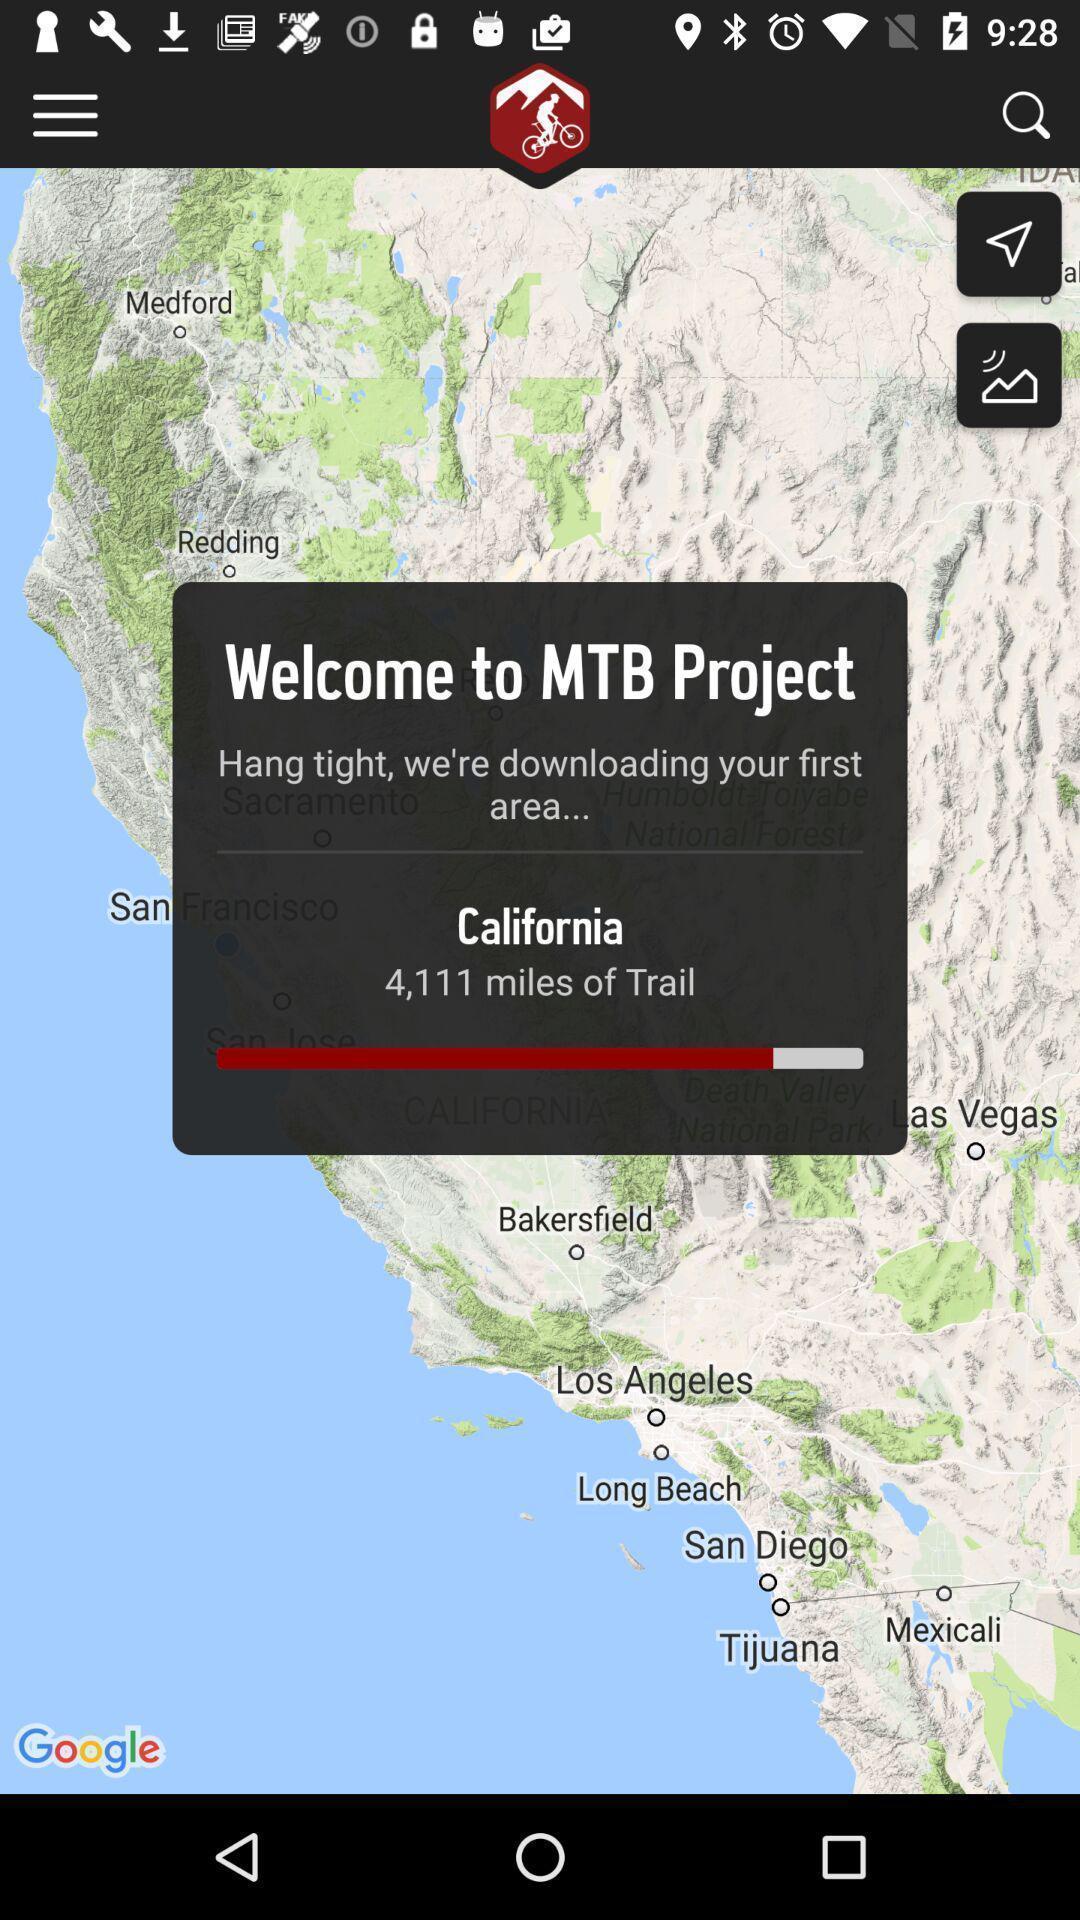Describe the visual elements of this screenshot. Welcome to mtb project in california. 